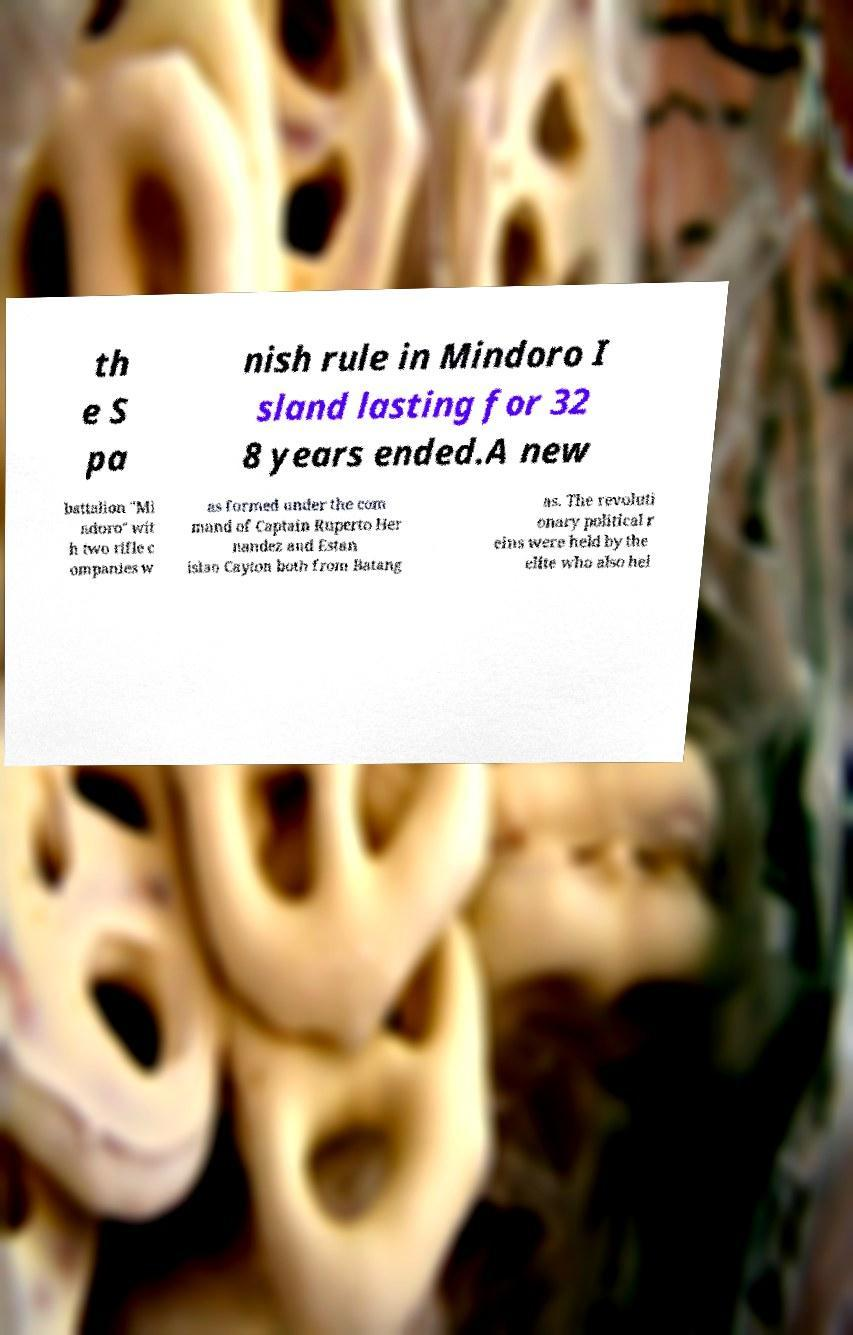What messages or text are displayed in this image? I need them in a readable, typed format. th e S pa nish rule in Mindoro I sland lasting for 32 8 years ended.A new battalion "Mi ndoro" wit h two rifle c ompanies w as formed under the com mand of Captain Ruperto Her nandez and Estan islao Cayton both from Batang as. The revoluti onary political r eins were held by the elite who also hel 